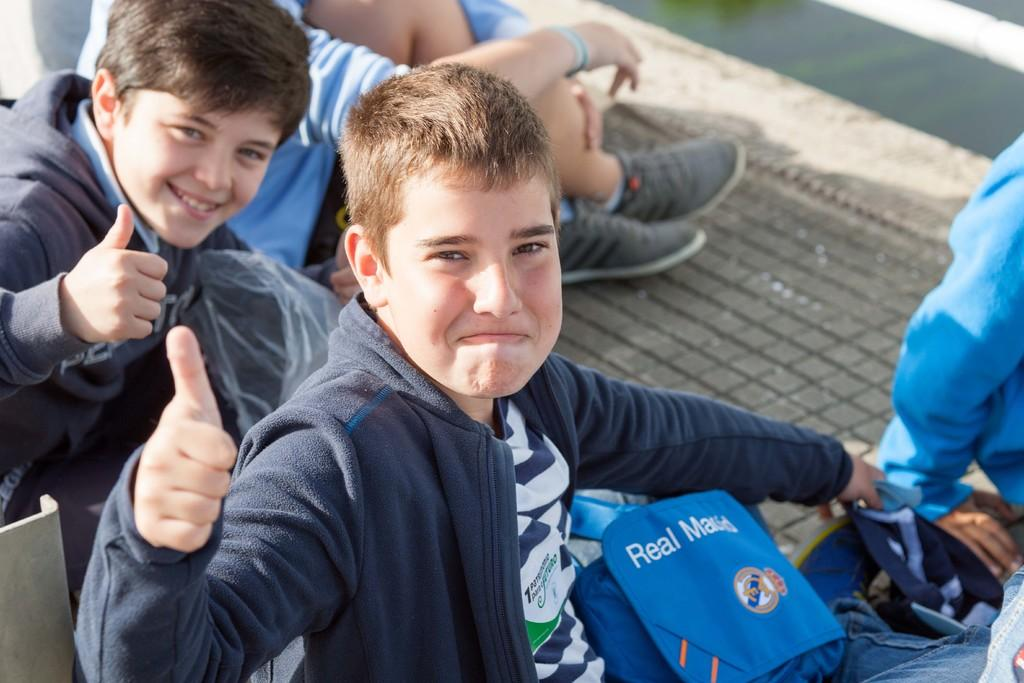What is the main subject of the image? The main subject of the image is a group of people. How are the people dressed in the image? The people are wearing different color dresses in the image. Can you identify any specific accessory one person is carrying? Yes, one person has a blue color bag in the image. Where are the people sitting in the image? The people are sitting on a path in the image. What type of stem can be seen growing from the person's head in the image? There is no stem growing from anyone's head in the image. 